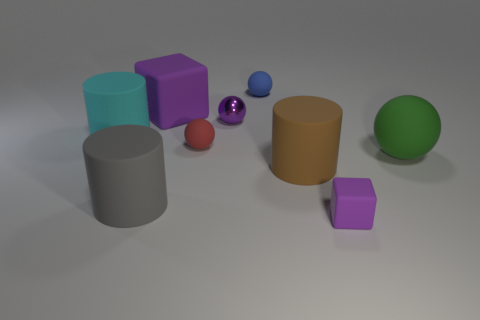Subtract all gray blocks. Subtract all purple spheres. How many blocks are left? 2 Add 1 tiny blue rubber things. How many objects exist? 10 Subtract all blocks. How many objects are left? 7 Add 3 big brown rubber cylinders. How many big brown rubber cylinders exist? 4 Subtract 2 purple cubes. How many objects are left? 7 Subtract all large brown matte objects. Subtract all blocks. How many objects are left? 6 Add 3 big brown matte cylinders. How many big brown matte cylinders are left? 4 